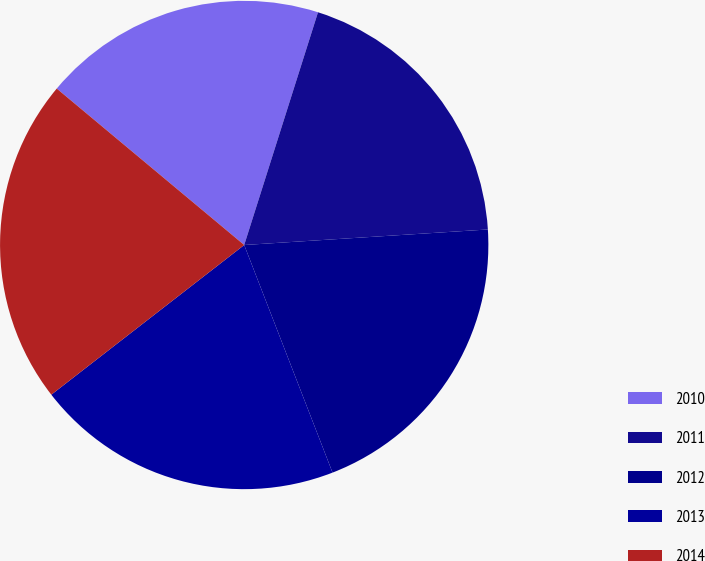Convert chart. <chart><loc_0><loc_0><loc_500><loc_500><pie_chart><fcel>2010<fcel>2011<fcel>2012<fcel>2013<fcel>2014<nl><fcel>18.82%<fcel>19.1%<fcel>20.12%<fcel>20.39%<fcel>21.57%<nl></chart> 